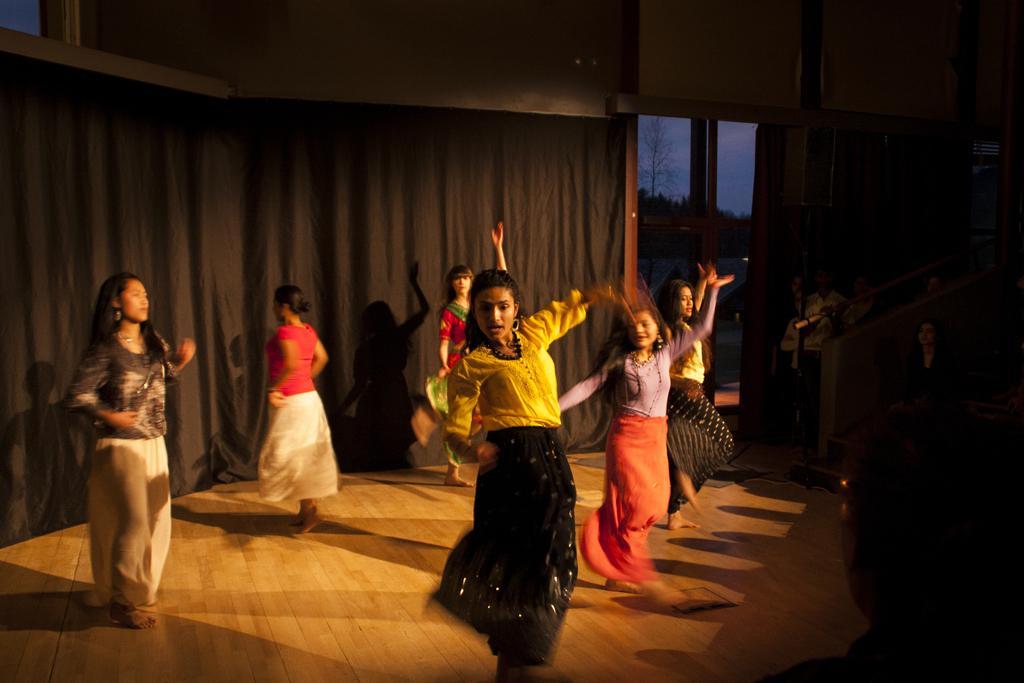Describe this image in one or two sentences. On a stage group of girls are performing dance and behind the girls there is a black curtain,in the front some people are watching their dance and there is a bright light focusing on the girls. 